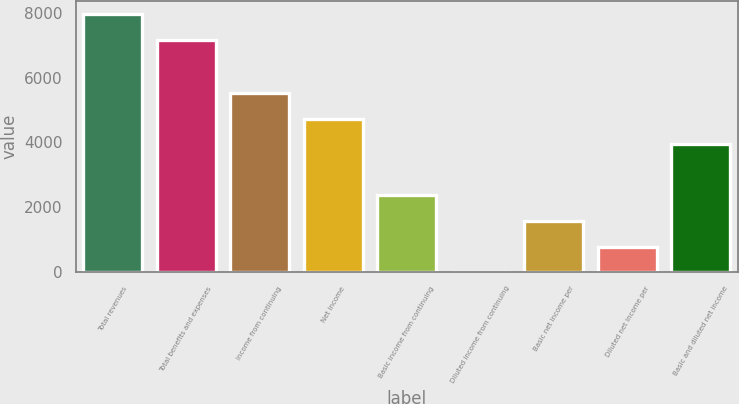Convert chart to OTSL. <chart><loc_0><loc_0><loc_500><loc_500><bar_chart><fcel>Total revenues<fcel>Total benefits and expenses<fcel>Income from continuing<fcel>Net income<fcel>Basic income from continuing<fcel>Diluted income from continuing<fcel>Basic net income per<fcel>Diluted net income per<fcel>Basic and diluted net income<nl><fcel>7950.12<fcel>7162<fcel>5517.62<fcel>4729.5<fcel>2365.14<fcel>0.78<fcel>1577.02<fcel>788.9<fcel>3941.38<nl></chart> 